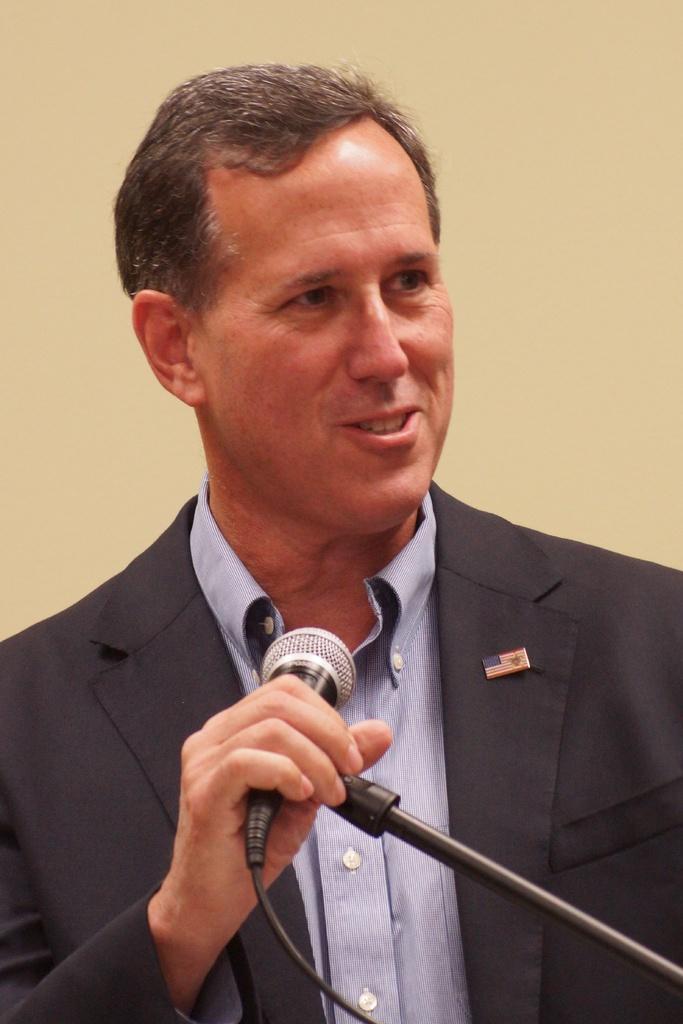Describe this image in one or two sentences. In this picture we can see man wore blazer holding mic with his hand and smiling. 